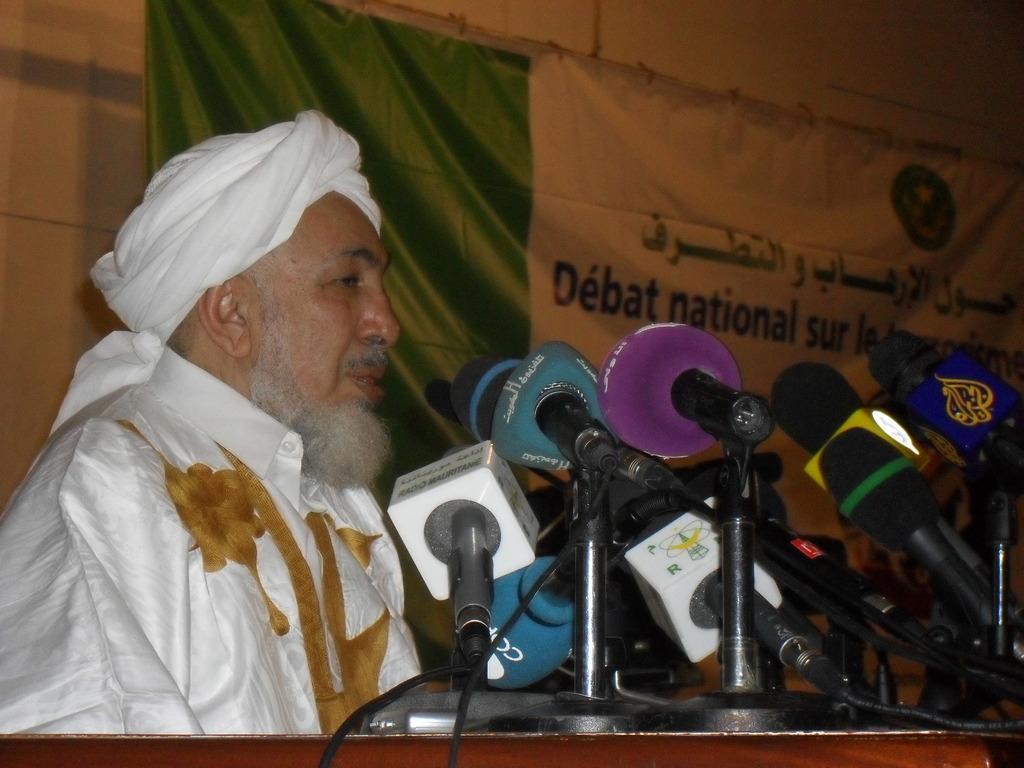How would you summarize this image in a sentence or two? In this picture I can see a man near the podium, there are mikes on the podium, and in the background there is a banner and a wall. 